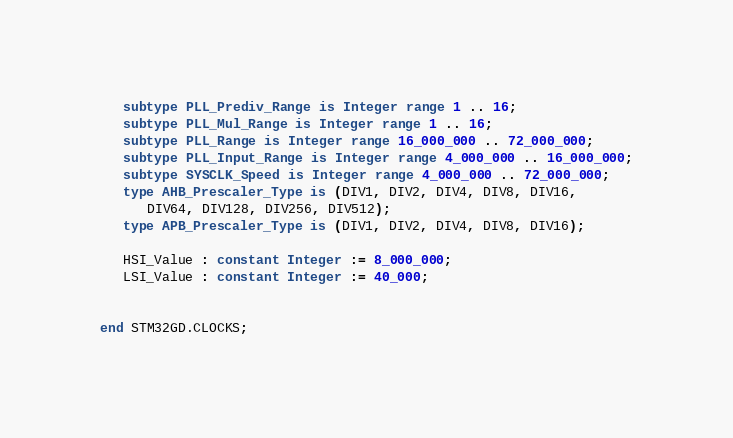Convert code to text. <code><loc_0><loc_0><loc_500><loc_500><_Ada_>   subtype PLL_Prediv_Range is Integer range 1 .. 16;
   subtype PLL_Mul_Range is Integer range 1 .. 16;
   subtype PLL_Range is Integer range 16_000_000 .. 72_000_000;
   subtype PLL_Input_Range is Integer range 4_000_000 .. 16_000_000;
   subtype SYSCLK_Speed is Integer range 4_000_000 .. 72_000_000;
   type AHB_Prescaler_Type is (DIV1, DIV2, DIV4, DIV8, DIV16, 
      DIV64, DIV128, DIV256, DIV512);
   type APB_Prescaler_Type is (DIV1, DIV2, DIV4, DIV8, DIV16);

   HSI_Value : constant Integer := 8_000_000;
   LSI_Value : constant Integer := 40_000;
   

end STM32GD.CLOCKS;
</code> 